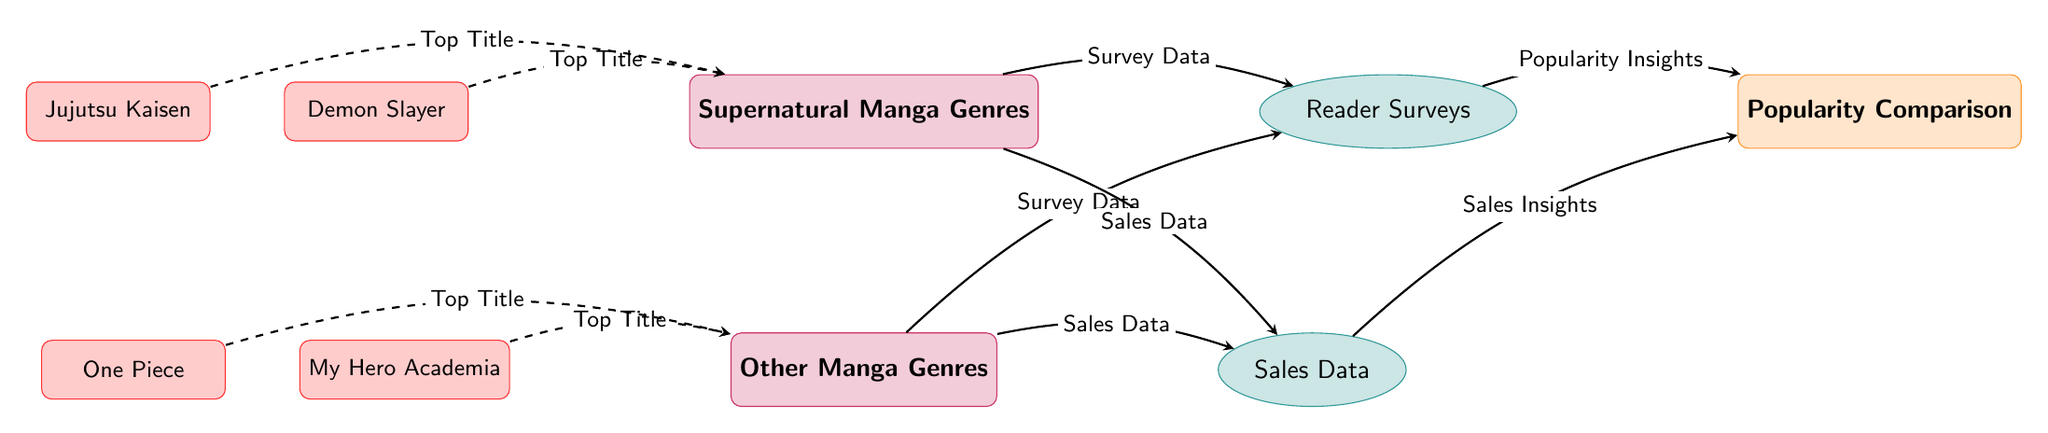What genre is compared in this diagram? The diagram has two main genres, which are supernatural manga genres and other manga genres. The title is indicated clearly in the nodes labeled "Supernatural Manga Genres" and "Other Manga Genres."
Answer: Supernatural Manga Genres How many nodes represent top titles in supernatural manga? There are two dashed arrows coming from the top titles, indicated as "Demon Slayer" and "Jujutsu Kaisen," which connect to the "Supernatural Manga Genres" node. This indicates that there are two nodes representing top titles in supernatural manga.
Answer: 2 What type of data is represented by the node connecting "Supernatural Manga Genres" to "Popularity Comparison"? The arrow is labeled "Popularity Insights," showing that the data captured from supernatural genres and comparisons is about popularity.
Answer: Popularity Insights What are the two types of data used for comparison in this diagram? The diagram distinguishes between two types of data: reader surveys and sales data, which both connect to popularity. This is indicated by the nodes labeled "Reader Surveys" and "Sales Data."
Answer: Reader Surveys and Sales Data Which series is shown as a top title for other manga genres? The top titles associated with the other genres node include "My Hero Academia" and "One Piece." Thus, these series are shown as top titles for other manga genres.
Answer: My Hero Academia and One Piece What relationship do the reader surveys have with the supernatural and other genres? The diagram indicates that both the supernatural and other manga genres direct survey data towards the “Reader Surveys” node, signifying that both genres utilize reader surveys for popularity analysis.
Answer: Survey Data What is the purpose of the popularity comparison in this diagram? The "Popularity Comparison" node synthesizes insights from both surveys and sales data related to supernatural and other manga genres, thus providing insights on how they compare in popularity.
Answer: To compare popularity How does the diagram classify the genre categories? The two main categories in this diagram are classified into "Supernatural Manga Genres" and "Other Manga Genres," highlighting that the comparison between these specific groupings is being analyzed for popularity.
Answer: Two categories What is the function of the dashed connections to the genre nodes? The dashed arrows represent top titles connecting to the genre nodes, specifically highlighting key works associated with each genre, indicating their significance and popularity in relation to the genre as a whole.
Answer: To highlight key works 